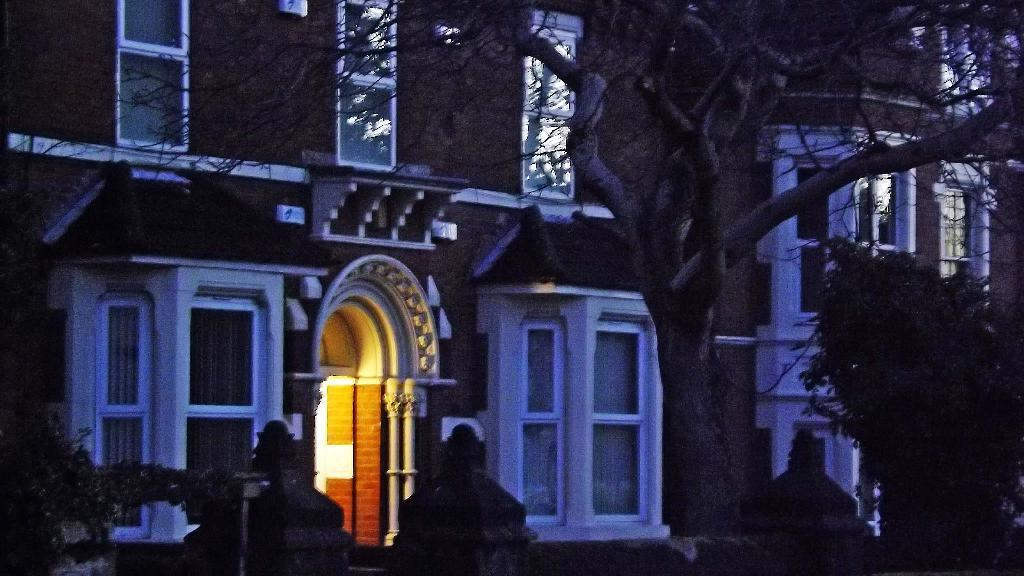What type of structure is visible in the image? There is a building in the image. What can be seen in the background of the image? There are trees in the image. Can you describe the interior of the building? There is a light inside the building. What is the closest object to the viewer in the image? There is a wall in the foreground of the image. What type of rice is being cooked by the brother in the image? There is no rice or brother present in the image. What is the person in the image reading? There is no person or reading material present in the image. 